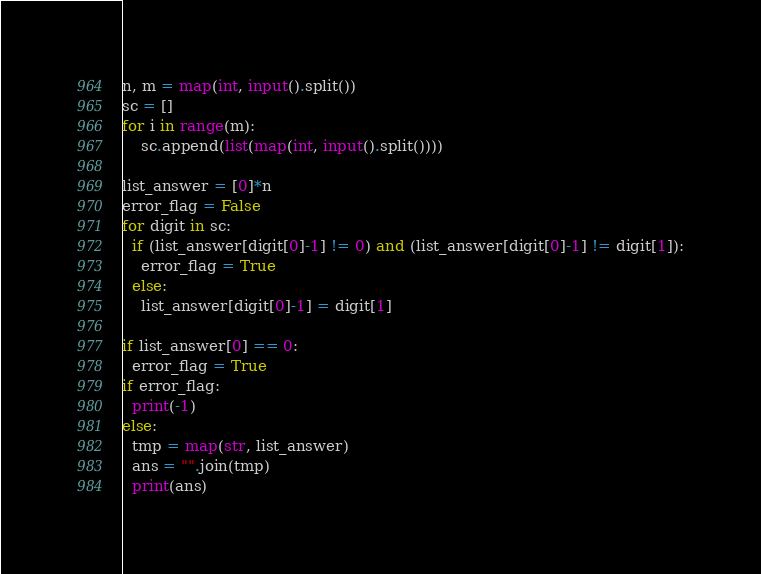<code> <loc_0><loc_0><loc_500><loc_500><_Python_>n, m = map(int, input().split())
sc = []
for i in range(m):
    sc.append(list(map(int, input().split())))
    
list_answer = [0]*n
error_flag = False
for digit in sc:
  if (list_answer[digit[0]-1] != 0) and (list_answer[digit[0]-1] != digit[1]):
    error_flag = True
  else:
  	list_answer[digit[0]-1] = digit[1]
    
if list_answer[0] == 0:
  error_flag = True
if error_flag:
  print(-1)
else:
  tmp = map(str, list_answer)
  ans = "".join(tmp)
  print(ans)</code> 